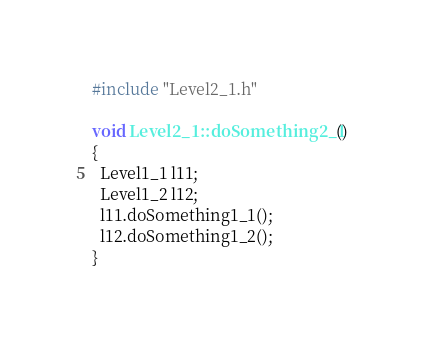<code> <loc_0><loc_0><loc_500><loc_500><_C++_>#include "Level2_1.h"

void Level2_1::doSomething2_1()
{
  Level1_1 l11;
  Level1_2 l12;
  l11.doSomething1_1();
  l12.doSomething1_2();
}</code> 